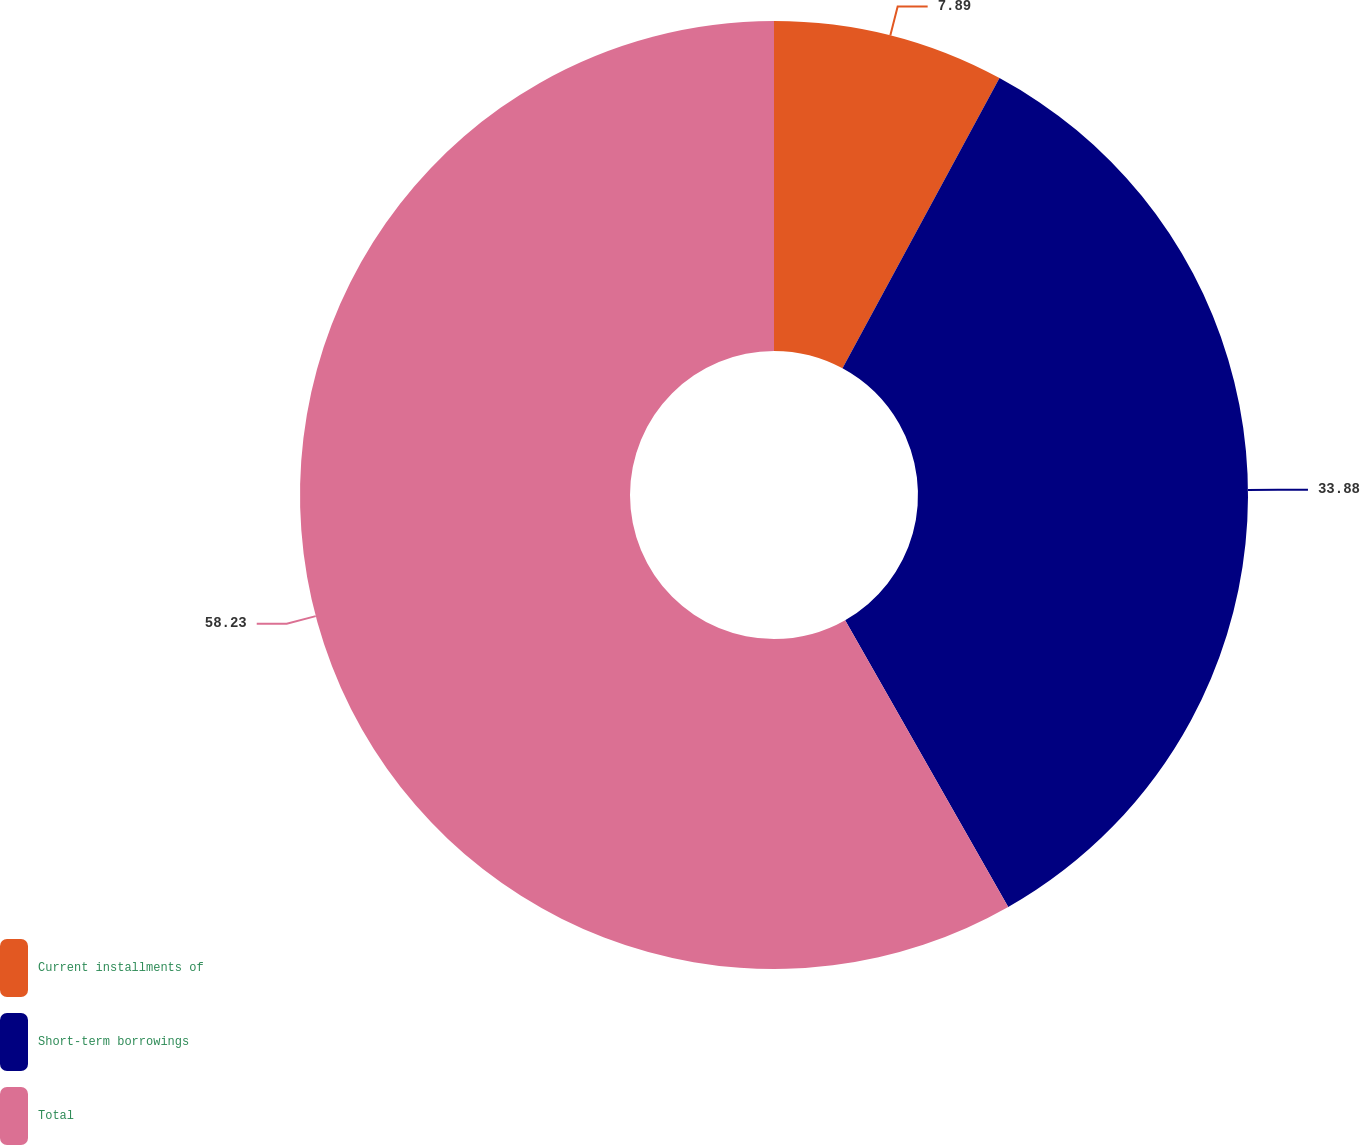Convert chart. <chart><loc_0><loc_0><loc_500><loc_500><pie_chart><fcel>Current installments of<fcel>Short-term borrowings<fcel>Total<nl><fcel>7.89%<fcel>33.88%<fcel>58.22%<nl></chart> 